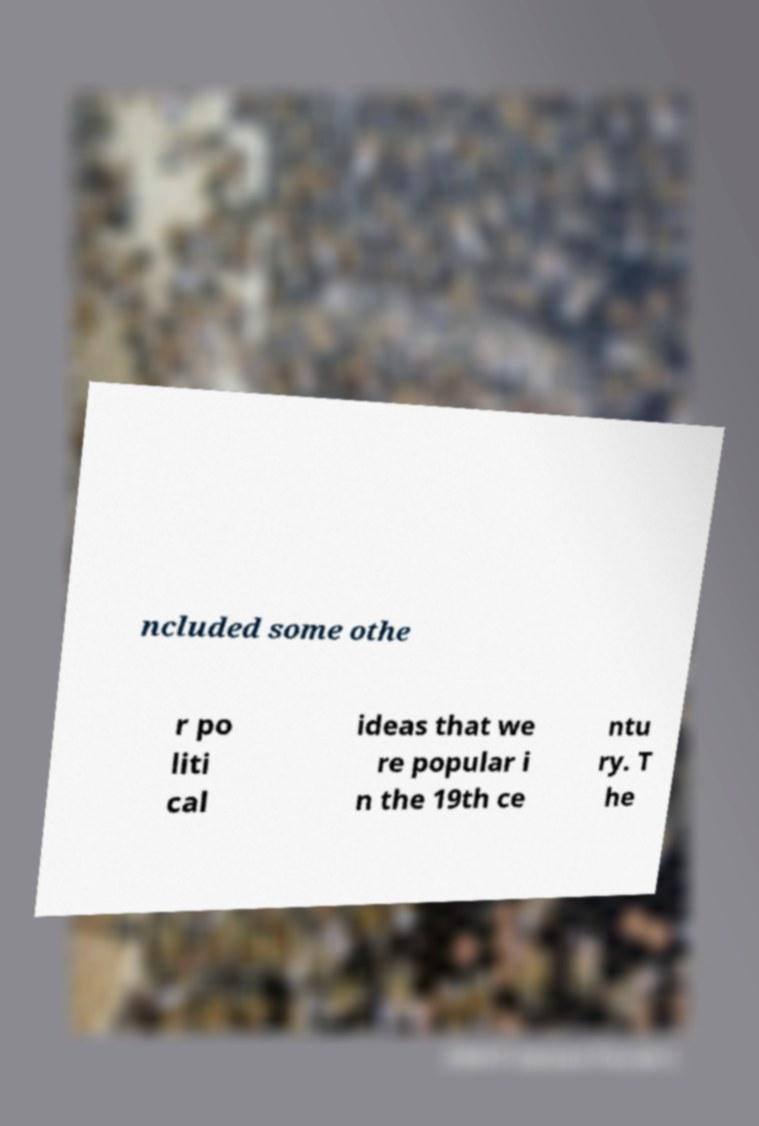I need the written content from this picture converted into text. Can you do that? ncluded some othe r po liti cal ideas that we re popular i n the 19th ce ntu ry. T he 